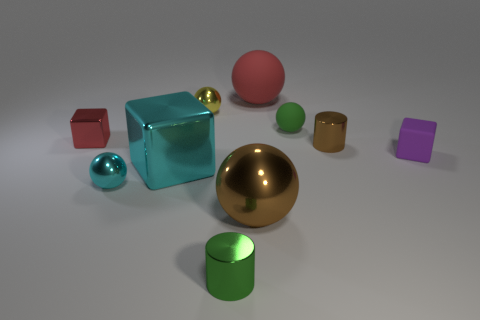How many other things are made of the same material as the tiny cyan sphere?
Make the answer very short. 6. Is the number of tiny purple matte objects that are behind the tiny brown cylinder less than the number of cyan metal cylinders?
Offer a terse response. No. Is the shape of the large cyan metal thing the same as the red metal object?
Ensure brevity in your answer.  Yes. What size is the cylinder right of the tiny green object behind the cylinder in front of the cyan ball?
Keep it short and to the point. Small. There is a green thing that is the same shape as the small cyan metallic object; what material is it?
Offer a very short reply. Rubber. There is a metallic block that is in front of the tiny metal object that is to the right of the red sphere; what is its size?
Give a very brief answer. Large. What color is the big block?
Ensure brevity in your answer.  Cyan. What number of small yellow metal objects are behind the brown metallic thing to the left of the large rubber sphere?
Your answer should be compact. 1. There is a green thing behind the tiny cyan ball; are there any purple objects that are behind it?
Your answer should be very brief. No. There is a large cyan shiny thing; are there any tiny green shiny things in front of it?
Keep it short and to the point. Yes. 